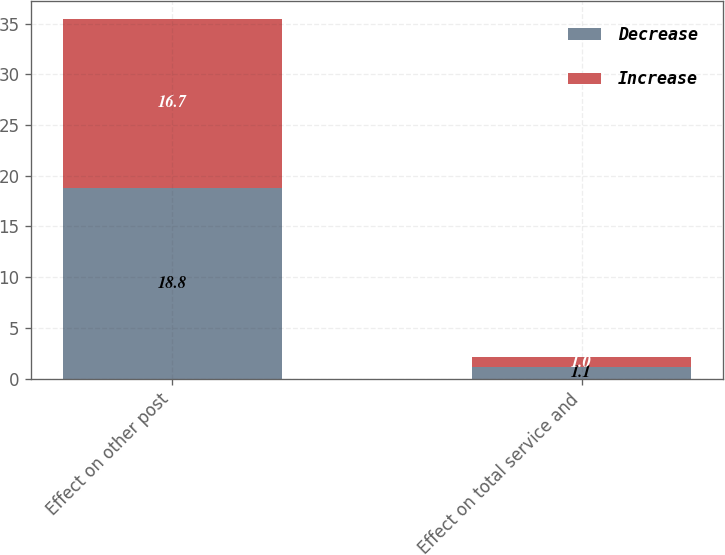<chart> <loc_0><loc_0><loc_500><loc_500><stacked_bar_chart><ecel><fcel>Effect on other post<fcel>Effect on total service and<nl><fcel>Decrease<fcel>18.8<fcel>1.1<nl><fcel>Increase<fcel>16.7<fcel>1<nl></chart> 